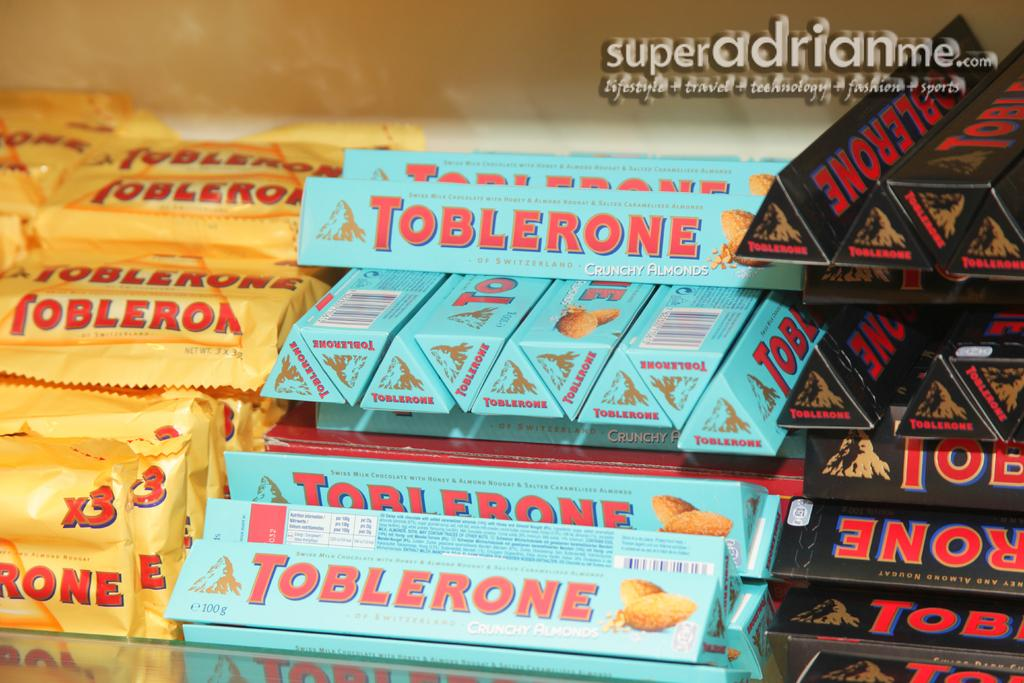What type of objects can be seen in the image? There are packets and boxes in the image. What is the surface on which the objects are placed? The glass platform is present in the image. What can be seen in the background of the image? There is a wall in the background of the image. Is there any text visible in the image? Yes, there is some text in the top right corner of the image. How many cups can be seen on the glass platform in the image? There are no cups present on the glass platform in the image. What type of currency is depicted in the image? There is no currency depicted in the image. 